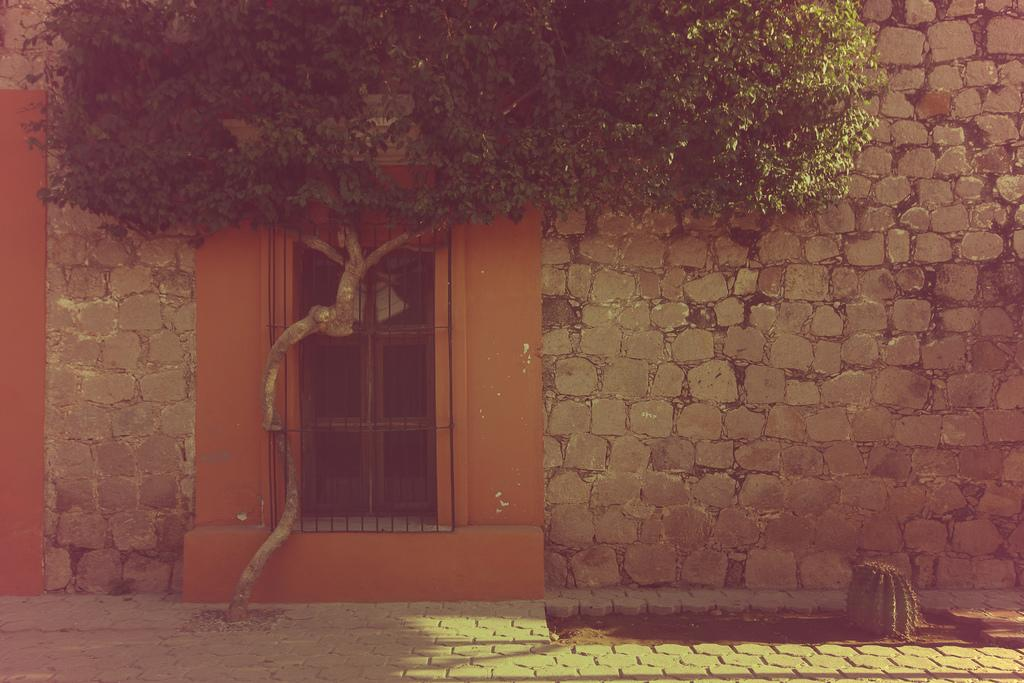What type of structure is in the picture? There is a building in the picture. What feature can be seen on the building? The building has a window. What type of vegetation is in the picture? There is a tree in the picture. How many jars of honey are on the window sill in the picture? There is no mention of honey or a window sill in the picture, so it is not possible to answer this question. 